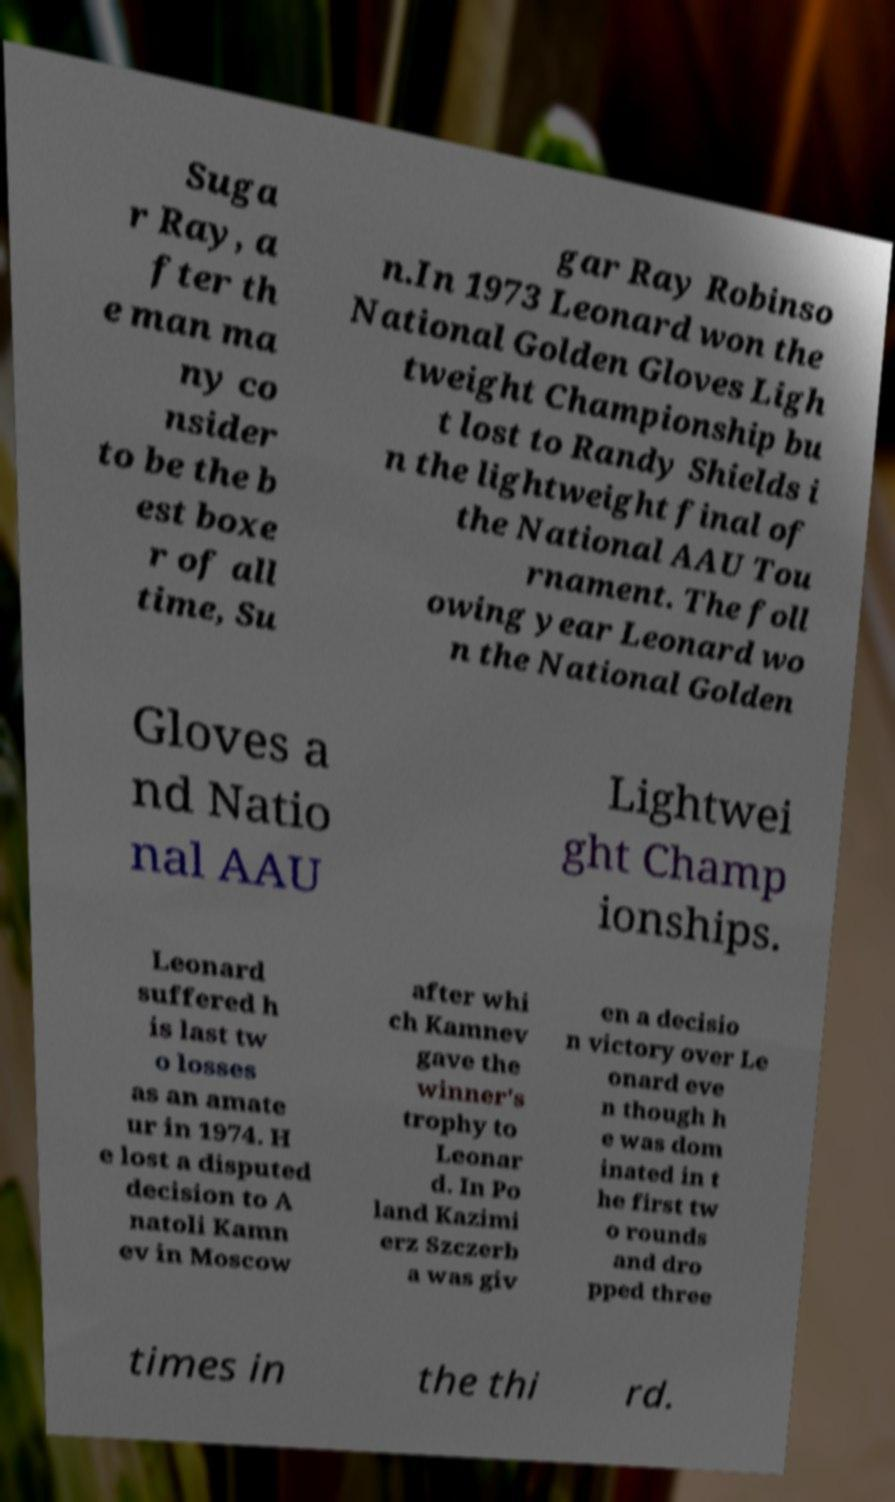I need the written content from this picture converted into text. Can you do that? Suga r Ray, a fter th e man ma ny co nsider to be the b est boxe r of all time, Su gar Ray Robinso n.In 1973 Leonard won the National Golden Gloves Ligh tweight Championship bu t lost to Randy Shields i n the lightweight final of the National AAU Tou rnament. The foll owing year Leonard wo n the National Golden Gloves a nd Natio nal AAU Lightwei ght Champ ionships. Leonard suffered h is last tw o losses as an amate ur in 1974. H e lost a disputed decision to A natoli Kamn ev in Moscow after whi ch Kamnev gave the winner's trophy to Leonar d. In Po land Kazimi erz Szczerb a was giv en a decisio n victory over Le onard eve n though h e was dom inated in t he first tw o rounds and dro pped three times in the thi rd. 